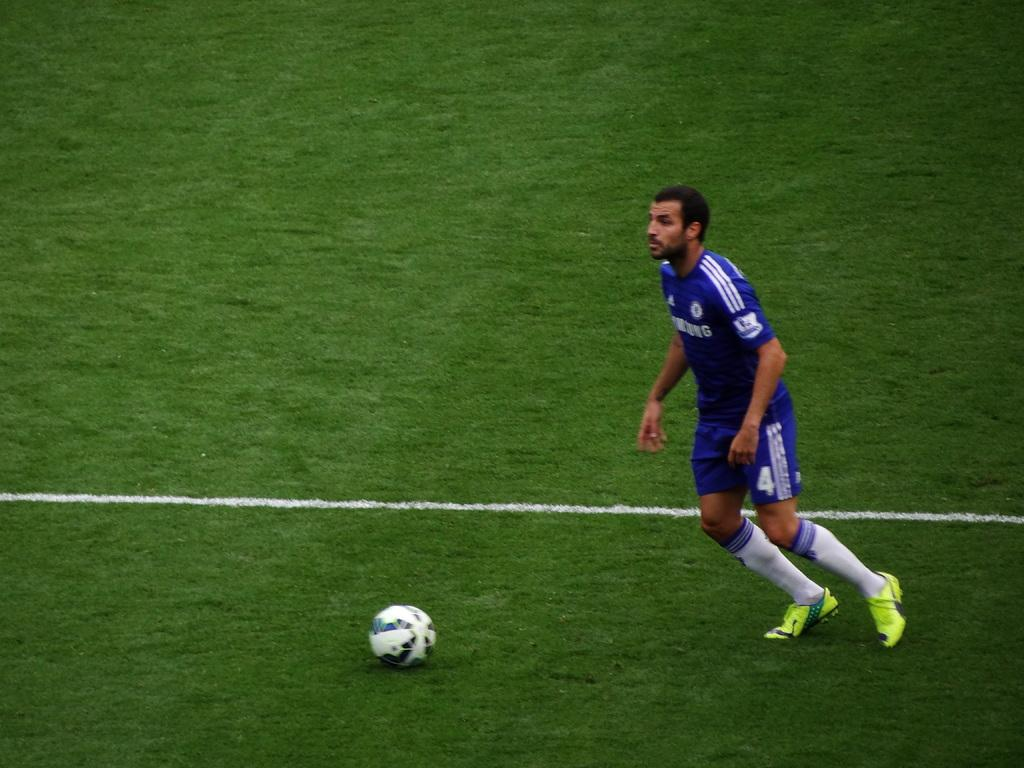<image>
Relay a brief, clear account of the picture shown. A male soccer player in a blue Samsung logo jersey 